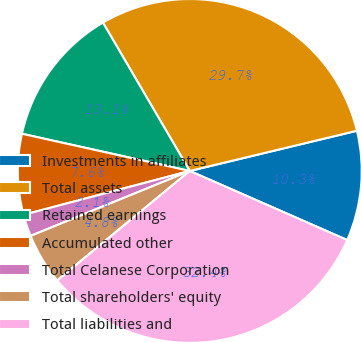Convert chart to OTSL. <chart><loc_0><loc_0><loc_500><loc_500><pie_chart><fcel>Investments in affiliates<fcel>Total assets<fcel>Retained earnings<fcel>Accumulated other<fcel>Total Celanese Corporation<fcel>Total shareholders' equity<fcel>Total liabilities and<nl><fcel>10.34%<fcel>29.67%<fcel>13.1%<fcel>7.58%<fcel>2.06%<fcel>4.82%<fcel>32.43%<nl></chart> 